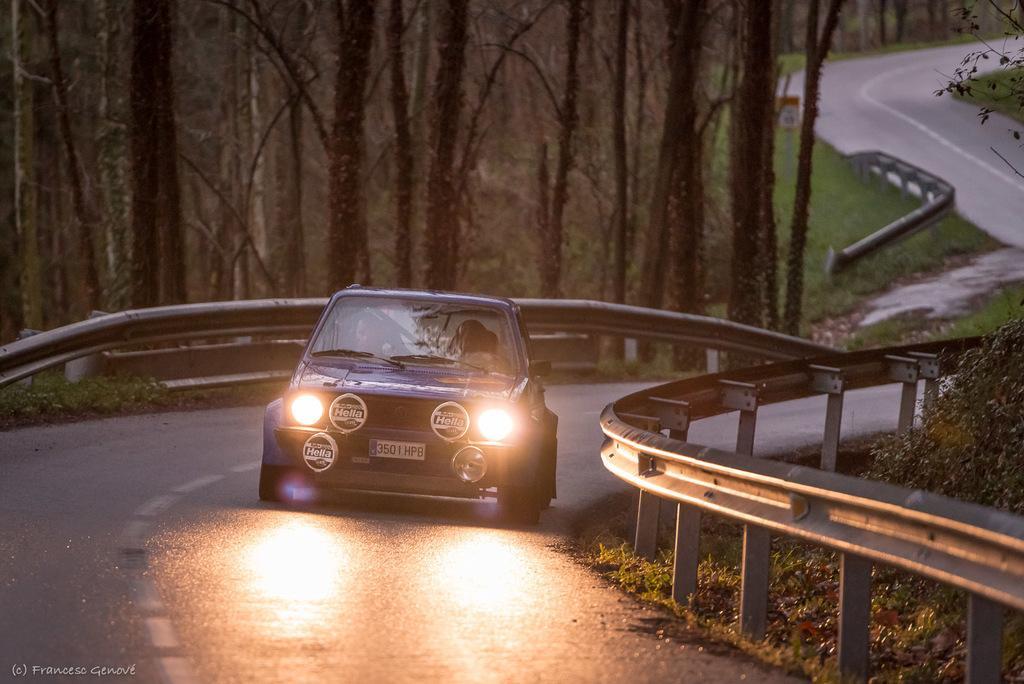Please provide a concise description of this image. In the picture we can see a road on it, we can see a car with a head light on and beside the road we can see railings beside the railing we can see grass plants, in the background we can see trees and grass surface. 